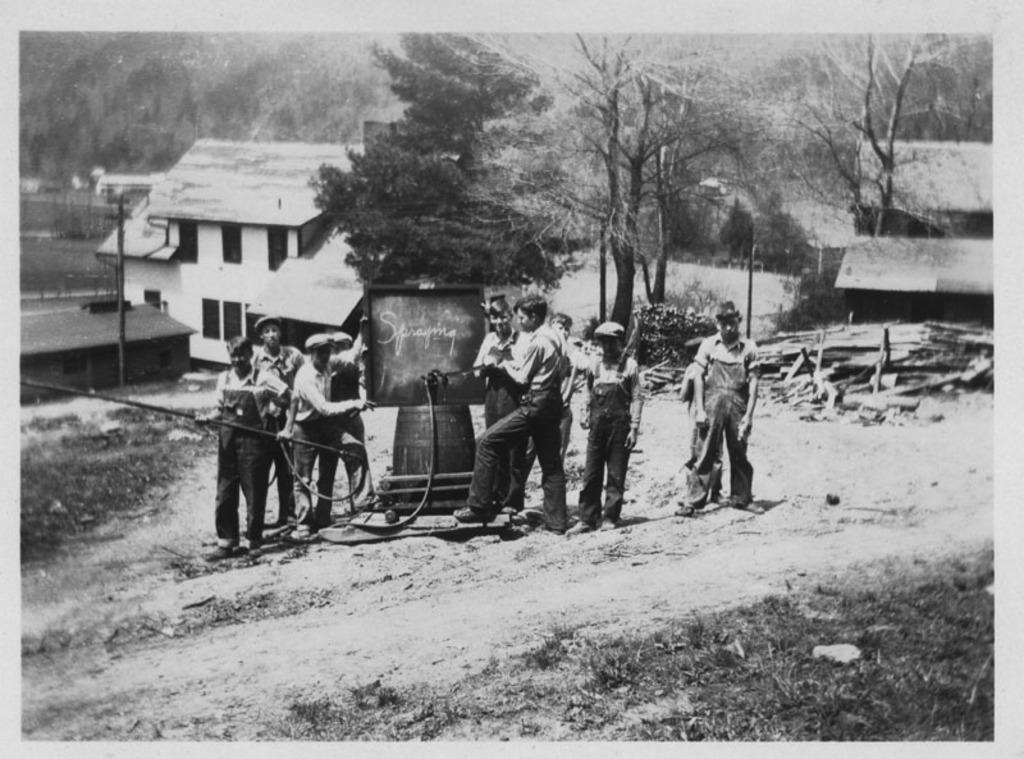What are the main subjects in the center of the image? There are people standing in the center of the image. What can be seen in the background of the image? There are sheds, trees, and a pole in the background of the image. What type of string is being used to hold up the sea in the image? There is no sea present in the image, and therefore no string is being used to hold it up. 